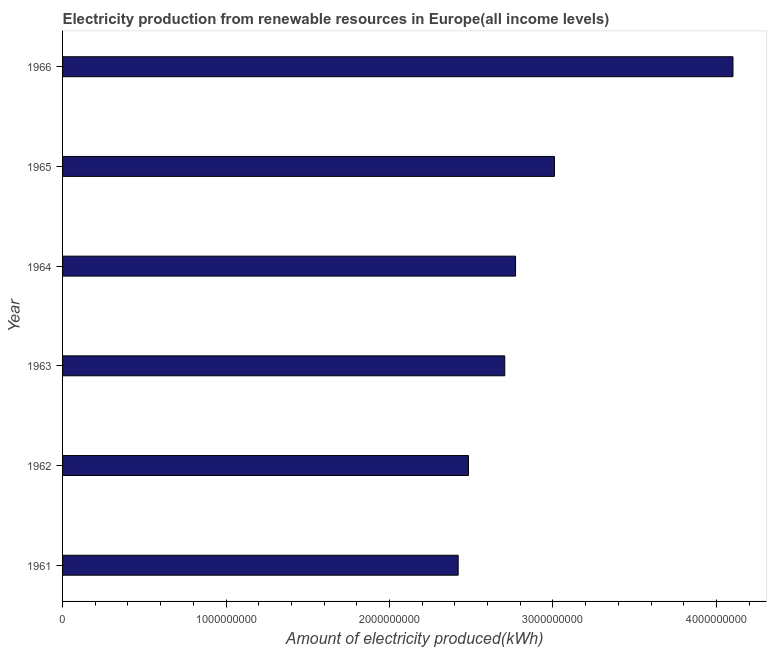What is the title of the graph?
Provide a short and direct response. Electricity production from renewable resources in Europe(all income levels). What is the label or title of the X-axis?
Your answer should be very brief. Amount of electricity produced(kWh). What is the amount of electricity produced in 1963?
Give a very brief answer. 2.70e+09. Across all years, what is the maximum amount of electricity produced?
Keep it short and to the point. 4.10e+09. Across all years, what is the minimum amount of electricity produced?
Make the answer very short. 2.42e+09. In which year was the amount of electricity produced maximum?
Provide a succinct answer. 1966. What is the sum of the amount of electricity produced?
Make the answer very short. 1.75e+1. What is the difference between the amount of electricity produced in 1961 and 1965?
Keep it short and to the point. -5.89e+08. What is the average amount of electricity produced per year?
Offer a very short reply. 2.91e+09. What is the median amount of electricity produced?
Your answer should be compact. 2.74e+09. In how many years, is the amount of electricity produced greater than 2600000000 kWh?
Offer a terse response. 4. What is the ratio of the amount of electricity produced in 1965 to that in 1966?
Your response must be concise. 0.73. Is the difference between the amount of electricity produced in 1964 and 1966 greater than the difference between any two years?
Your answer should be very brief. No. What is the difference between the highest and the second highest amount of electricity produced?
Provide a short and direct response. 1.09e+09. Is the sum of the amount of electricity produced in 1962 and 1964 greater than the maximum amount of electricity produced across all years?
Offer a terse response. Yes. What is the difference between the highest and the lowest amount of electricity produced?
Give a very brief answer. 1.68e+09. Are all the bars in the graph horizontal?
Keep it short and to the point. Yes. How many years are there in the graph?
Provide a succinct answer. 6. Are the values on the major ticks of X-axis written in scientific E-notation?
Offer a terse response. No. What is the Amount of electricity produced(kWh) in 1961?
Give a very brief answer. 2.42e+09. What is the Amount of electricity produced(kWh) in 1962?
Ensure brevity in your answer.  2.48e+09. What is the Amount of electricity produced(kWh) in 1963?
Provide a short and direct response. 2.70e+09. What is the Amount of electricity produced(kWh) in 1964?
Make the answer very short. 2.77e+09. What is the Amount of electricity produced(kWh) in 1965?
Make the answer very short. 3.01e+09. What is the Amount of electricity produced(kWh) in 1966?
Your answer should be compact. 4.10e+09. What is the difference between the Amount of electricity produced(kWh) in 1961 and 1962?
Your response must be concise. -6.30e+07. What is the difference between the Amount of electricity produced(kWh) in 1961 and 1963?
Make the answer very short. -2.85e+08. What is the difference between the Amount of electricity produced(kWh) in 1961 and 1964?
Your answer should be compact. -3.51e+08. What is the difference between the Amount of electricity produced(kWh) in 1961 and 1965?
Provide a short and direct response. -5.89e+08. What is the difference between the Amount of electricity produced(kWh) in 1961 and 1966?
Provide a short and direct response. -1.68e+09. What is the difference between the Amount of electricity produced(kWh) in 1962 and 1963?
Your response must be concise. -2.22e+08. What is the difference between the Amount of electricity produced(kWh) in 1962 and 1964?
Provide a short and direct response. -2.88e+08. What is the difference between the Amount of electricity produced(kWh) in 1962 and 1965?
Provide a short and direct response. -5.26e+08. What is the difference between the Amount of electricity produced(kWh) in 1962 and 1966?
Provide a succinct answer. -1.62e+09. What is the difference between the Amount of electricity produced(kWh) in 1963 and 1964?
Offer a terse response. -6.60e+07. What is the difference between the Amount of electricity produced(kWh) in 1963 and 1965?
Keep it short and to the point. -3.04e+08. What is the difference between the Amount of electricity produced(kWh) in 1963 and 1966?
Your answer should be very brief. -1.40e+09. What is the difference between the Amount of electricity produced(kWh) in 1964 and 1965?
Your answer should be compact. -2.38e+08. What is the difference between the Amount of electricity produced(kWh) in 1964 and 1966?
Give a very brief answer. -1.33e+09. What is the difference between the Amount of electricity produced(kWh) in 1965 and 1966?
Your answer should be compact. -1.09e+09. What is the ratio of the Amount of electricity produced(kWh) in 1961 to that in 1963?
Make the answer very short. 0.9. What is the ratio of the Amount of electricity produced(kWh) in 1961 to that in 1964?
Your answer should be very brief. 0.87. What is the ratio of the Amount of electricity produced(kWh) in 1961 to that in 1965?
Offer a very short reply. 0.8. What is the ratio of the Amount of electricity produced(kWh) in 1961 to that in 1966?
Offer a very short reply. 0.59. What is the ratio of the Amount of electricity produced(kWh) in 1962 to that in 1963?
Your answer should be compact. 0.92. What is the ratio of the Amount of electricity produced(kWh) in 1962 to that in 1964?
Make the answer very short. 0.9. What is the ratio of the Amount of electricity produced(kWh) in 1962 to that in 1965?
Offer a very short reply. 0.82. What is the ratio of the Amount of electricity produced(kWh) in 1962 to that in 1966?
Provide a succinct answer. 0.6. What is the ratio of the Amount of electricity produced(kWh) in 1963 to that in 1964?
Your response must be concise. 0.98. What is the ratio of the Amount of electricity produced(kWh) in 1963 to that in 1965?
Give a very brief answer. 0.9. What is the ratio of the Amount of electricity produced(kWh) in 1963 to that in 1966?
Your answer should be very brief. 0.66. What is the ratio of the Amount of electricity produced(kWh) in 1964 to that in 1965?
Your response must be concise. 0.92. What is the ratio of the Amount of electricity produced(kWh) in 1964 to that in 1966?
Provide a short and direct response. 0.68. What is the ratio of the Amount of electricity produced(kWh) in 1965 to that in 1966?
Your answer should be compact. 0.73. 